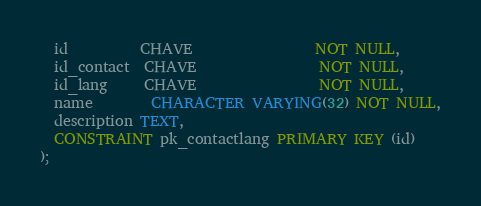Convert code to text. <code><loc_0><loc_0><loc_500><loc_500><_SQL_>  id          CHAVE                 NOT NULL,
  id_contact  CHAVE                 NOT NULL,
  id_lang     CHAVE                 NOT NULL,
  name        CHARACTER VARYING(32) NOT NULL,
  description TEXT,
  CONSTRAINT pk_contactlang PRIMARY KEY (id)
);</code> 